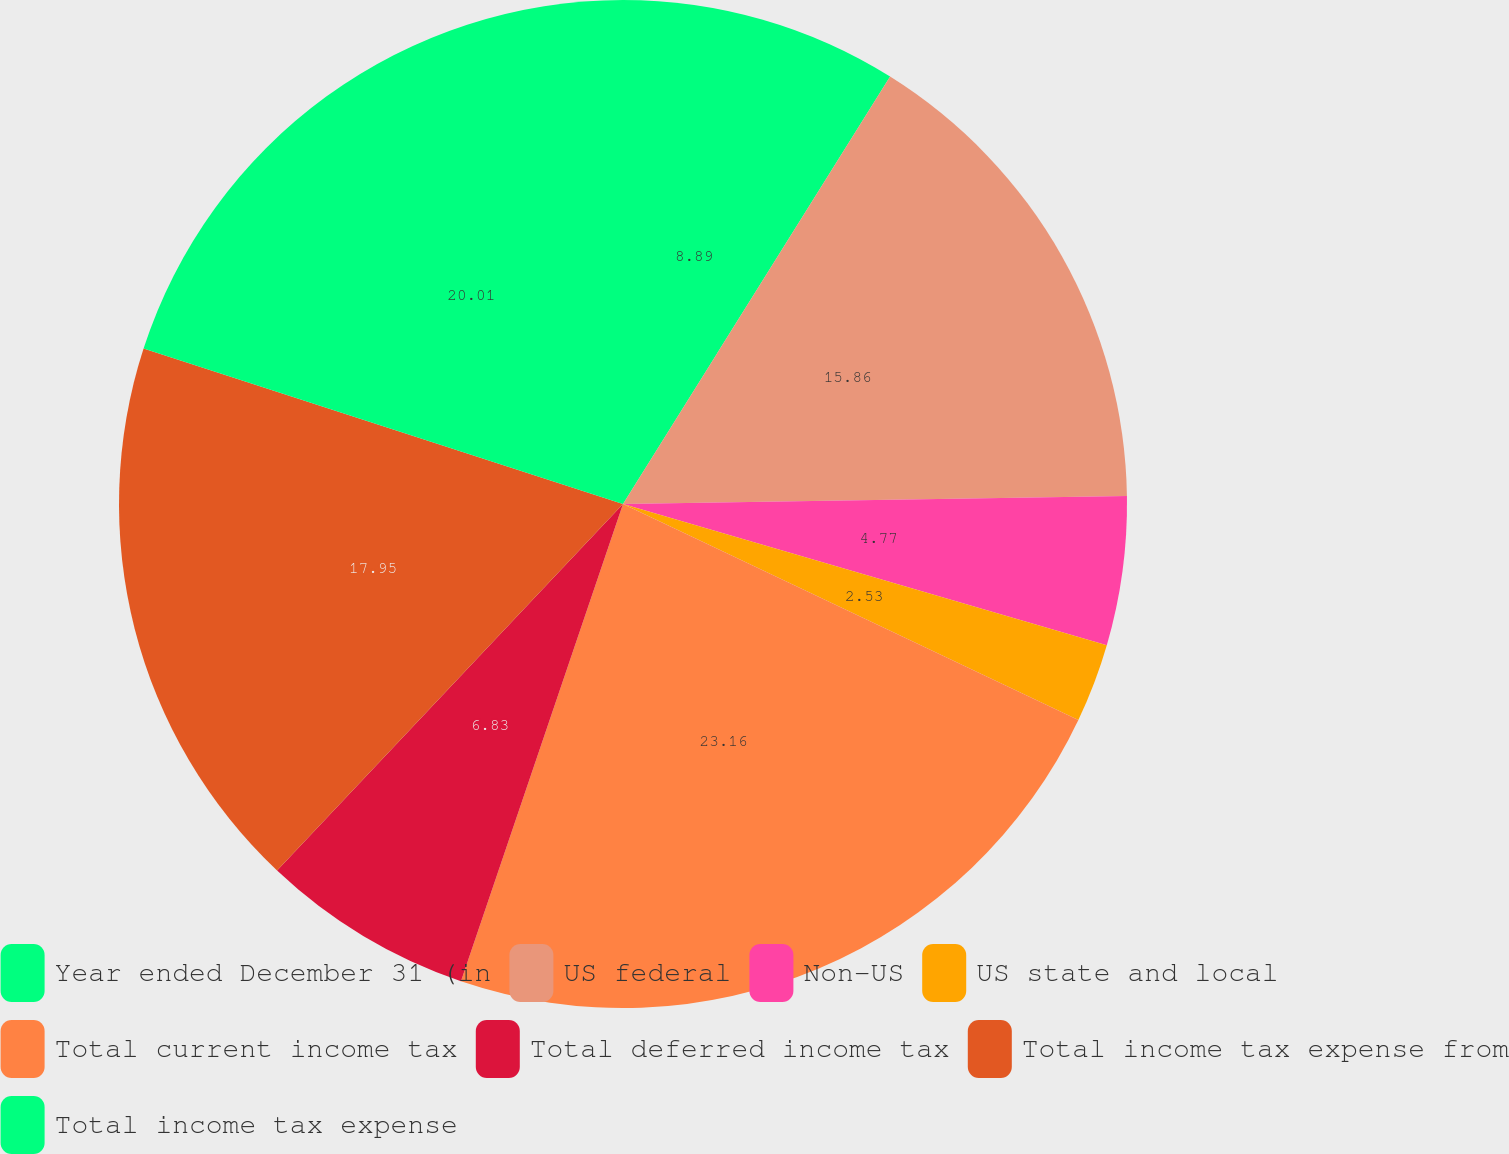Convert chart. <chart><loc_0><loc_0><loc_500><loc_500><pie_chart><fcel>Year ended December 31 (in<fcel>US federal<fcel>Non-US<fcel>US state and local<fcel>Total current income tax<fcel>Total deferred income tax<fcel>Total income tax expense from<fcel>Total income tax expense<nl><fcel>8.89%<fcel>15.86%<fcel>4.77%<fcel>2.53%<fcel>23.16%<fcel>6.83%<fcel>17.95%<fcel>20.01%<nl></chart> 